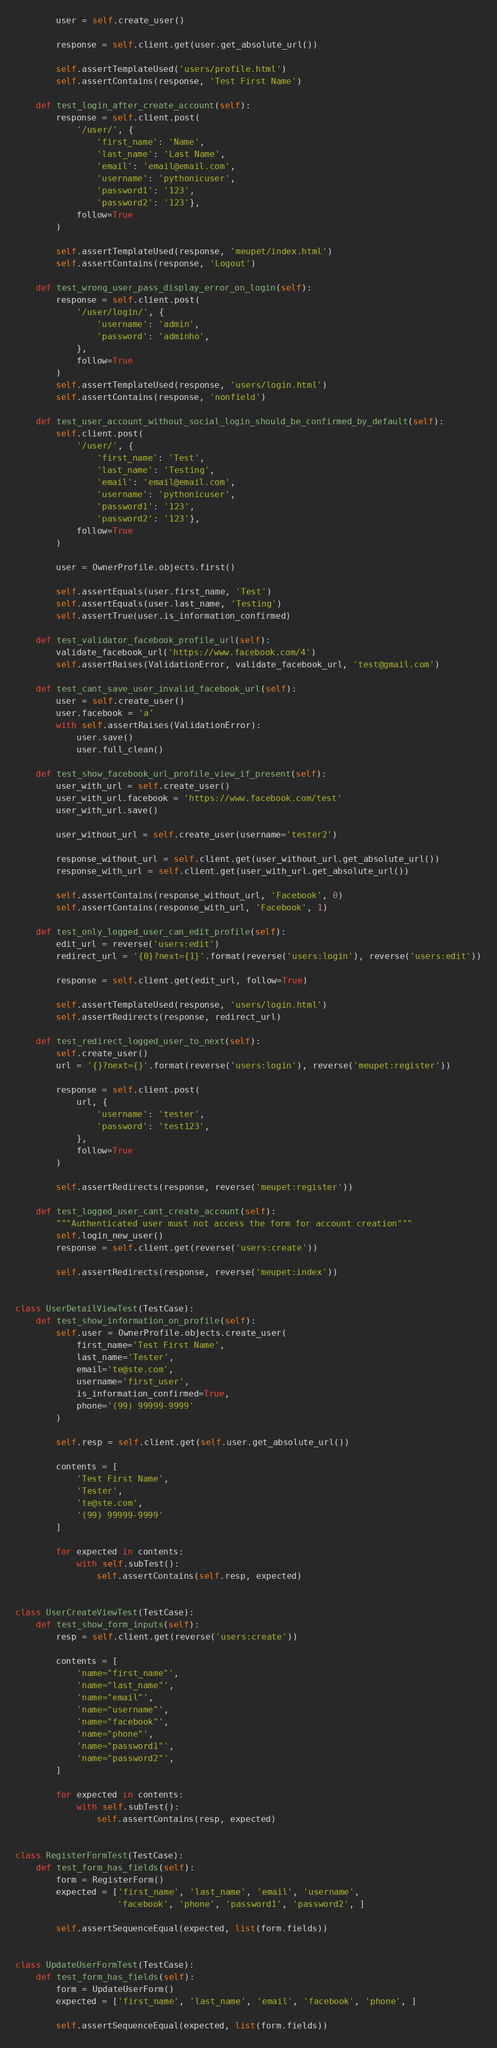<code> <loc_0><loc_0><loc_500><loc_500><_Python_>        user = self.create_user()

        response = self.client.get(user.get_absolute_url())

        self.assertTemplateUsed('users/profile.html')
        self.assertContains(response, 'Test First Name')

    def test_login_after_create_account(self):
        response = self.client.post(
            '/user/', {
                'first_name': 'Name',
                'last_name': 'Last Name',
                'email': 'email@email.com',
                'username': 'pythonicuser',
                'password1': '123',
                'password2': '123'},
            follow=True
        )

        self.assertTemplateUsed(response, 'meupet/index.html')
        self.assertContains(response, 'Logout')

    def test_wrong_user_pass_display_error_on_login(self):
        response = self.client.post(
            '/user/login/', {
                'username': 'admin',
                'password': 'adminho',
            },
            follow=True
        )
        self.assertTemplateUsed(response, 'users/login.html')
        self.assertContains(response, 'nonfield')

    def test_user_account_without_social_login_should_be_confirmed_by_default(self):
        self.client.post(
            '/user/', {
                'first_name': 'Test',
                'last_name': 'Testing',
                'email': 'email@email.com',
                'username': 'pythonicuser',
                'password1': '123',
                'password2': '123'},
            follow=True
        )

        user = OwnerProfile.objects.first()

        self.assertEquals(user.first_name, 'Test')
        self.assertEquals(user.last_name, 'Testing')
        self.assertTrue(user.is_information_confirmed)

    def test_validator_facebook_profile_url(self):
        validate_facebook_url('https://www.facebook.com/4')
        self.assertRaises(ValidationError, validate_facebook_url, 'test@gmail.com')

    def test_cant_save_user_invalid_facebook_url(self):
        user = self.create_user()
        user.facebook = 'a'
        with self.assertRaises(ValidationError):
            user.save()
            user.full_clean()

    def test_show_facebook_url_profile_view_if_present(self):
        user_with_url = self.create_user()
        user_with_url.facebook = 'https://www.facebook.com/test'
        user_with_url.save()

        user_without_url = self.create_user(username='tester2')

        response_without_url = self.client.get(user_without_url.get_absolute_url())
        response_with_url = self.client.get(user_with_url.get_absolute_url())

        self.assertContains(response_without_url, 'Facebook', 0)
        self.assertContains(response_with_url, 'Facebook', 1)

    def test_only_logged_user_can_edit_profile(self):
        edit_url = reverse('users:edit')
        redirect_url = '{0}?next={1}'.format(reverse('users:login'), reverse('users:edit'))

        response = self.client.get(edit_url, follow=True)

        self.assertTemplateUsed(response, 'users/login.html')
        self.assertRedirects(response, redirect_url)

    def test_redirect_logged_user_to_next(self):
        self.create_user()
        url = '{}?next={}'.format(reverse('users:login'), reverse('meupet:register'))

        response = self.client.post(
            url, {
                'username': 'tester',
                'password': 'test123',
            },
            follow=True
        )

        self.assertRedirects(response, reverse('meupet:register'))

    def test_logged_user_cant_create_account(self):
        """Authenticated user must not access the form for account creation"""
        self.login_new_user()
        response = self.client.get(reverse('users:create'))

        self.assertRedirects(response, reverse('meupet:index'))


class UserDetailViewTest(TestCase):
    def test_show_information_on_profile(self):
        self.user = OwnerProfile.objects.create_user(
            first_name='Test First Name',
            last_name='Tester',
            email='te@ste.com',
            username='first_user',
            is_information_confirmed=True,
            phone='(99) 99999-9999'
        )

        self.resp = self.client.get(self.user.get_absolute_url())

        contents = [
            'Test First Name',
            'Tester',
            'te@ste.com',
            '(99) 99999-9999'
        ]

        for expected in contents:
            with self.subTest():
                self.assertContains(self.resp, expected)


class UserCreateViewTest(TestCase):
    def test_show_form_inputs(self):
        resp = self.client.get(reverse('users:create'))

        contents = [
            'name="first_name"',
            'name="last_name"',
            'name="email"',
            'name="username"',
            'name="facebook"',
            'name="phone"',
            'name="password1"',
            'name="password2"',
        ]

        for expected in contents:
            with self.subTest():
                self.assertContains(resp, expected)


class RegisterFormTest(TestCase):
    def test_form_has_fields(self):
        form = RegisterForm()
        expected = ['first_name', 'last_name', 'email', 'username',
                    'facebook', 'phone', 'password1', 'password2', ]

        self.assertSequenceEqual(expected, list(form.fields))


class UpdateUserFormTest(TestCase):
    def test_form_has_fields(self):
        form = UpdateUserForm()
        expected = ['first_name', 'last_name', 'email', 'facebook', 'phone', ]

        self.assertSequenceEqual(expected, list(form.fields))
</code> 